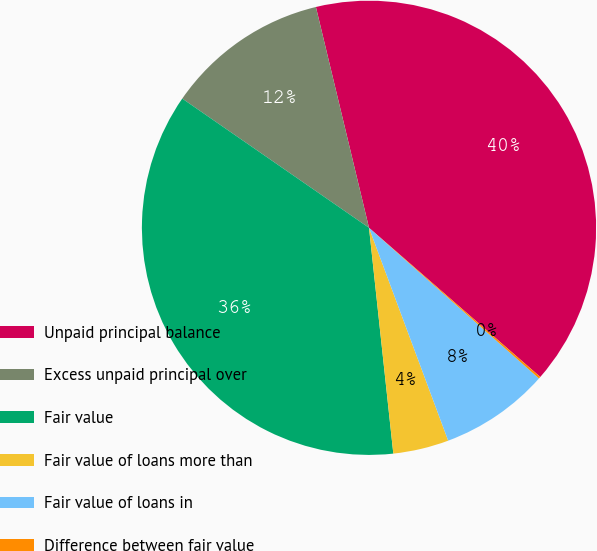Convert chart to OTSL. <chart><loc_0><loc_0><loc_500><loc_500><pie_chart><fcel>Unpaid principal balance<fcel>Excess unpaid principal over<fcel>Fair value<fcel>Fair value of loans more than<fcel>Fair value of loans in<fcel>Difference between fair value<nl><fcel>40.16%<fcel>11.61%<fcel>36.34%<fcel>3.96%<fcel>7.79%<fcel>0.14%<nl></chart> 